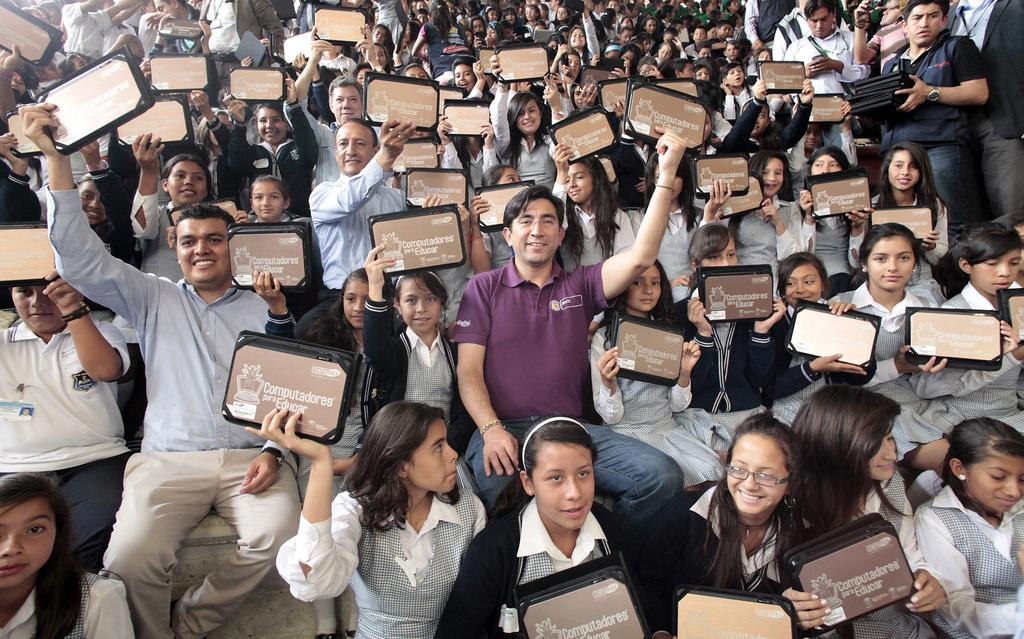How many people are in the image? There are people in the image, but the exact number is not specified. What are the people holding in the image? The people are holding boards in the image. What type of rake is being used by the expert in the image? There is no rake or expert present in the image; it only features people holding boards. 